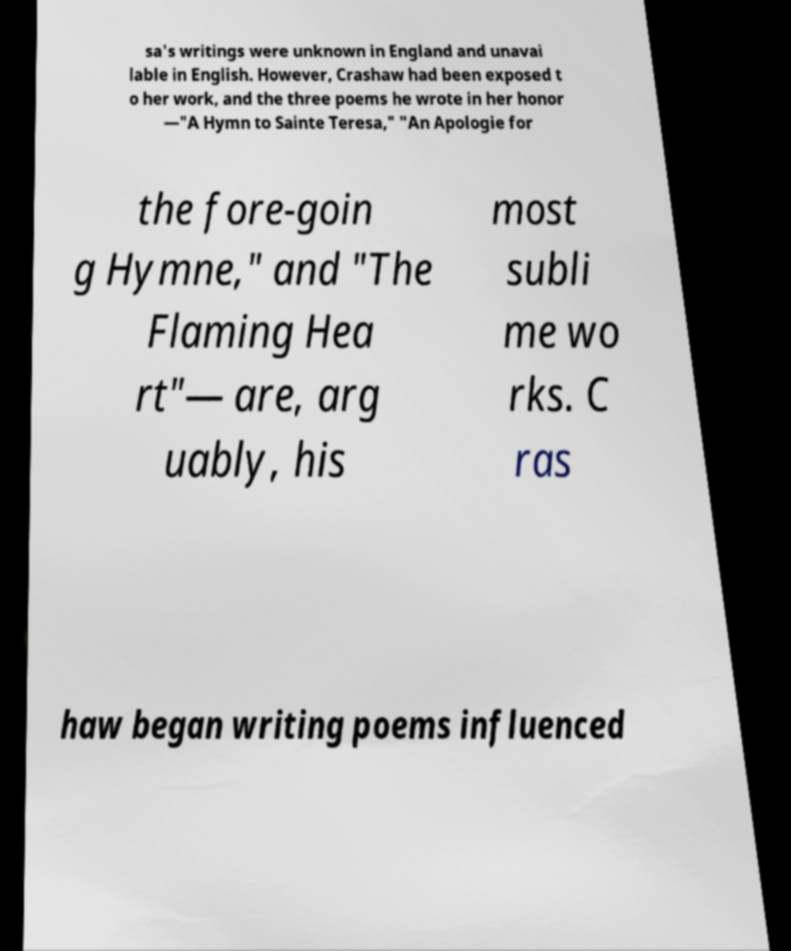Could you extract and type out the text from this image? sa's writings were unknown in England and unavai lable in English. However, Crashaw had been exposed t o her work, and the three poems he wrote in her honor —"A Hymn to Sainte Teresa," "An Apologie for the fore-goin g Hymne," and "The Flaming Hea rt"— are, arg uably, his most subli me wo rks. C ras haw began writing poems influenced 